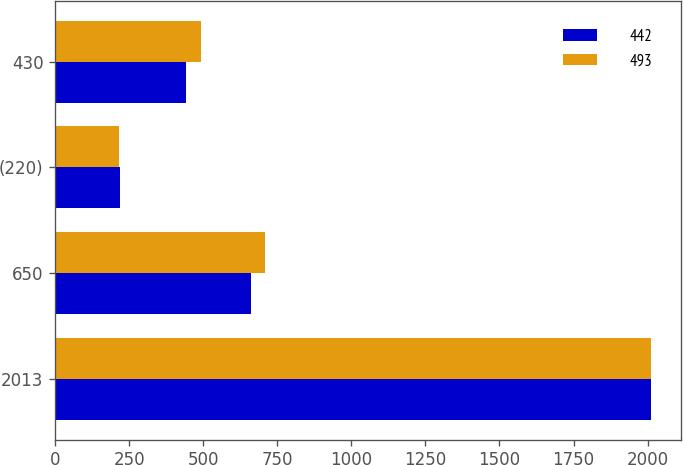Convert chart to OTSL. <chart><loc_0><loc_0><loc_500><loc_500><stacked_bar_chart><ecel><fcel>2013<fcel>650<fcel>(220)<fcel>430<nl><fcel>442<fcel>2012<fcel>661<fcel>219<fcel>442<nl><fcel>493<fcel>2011<fcel>707<fcel>214<fcel>493<nl></chart> 